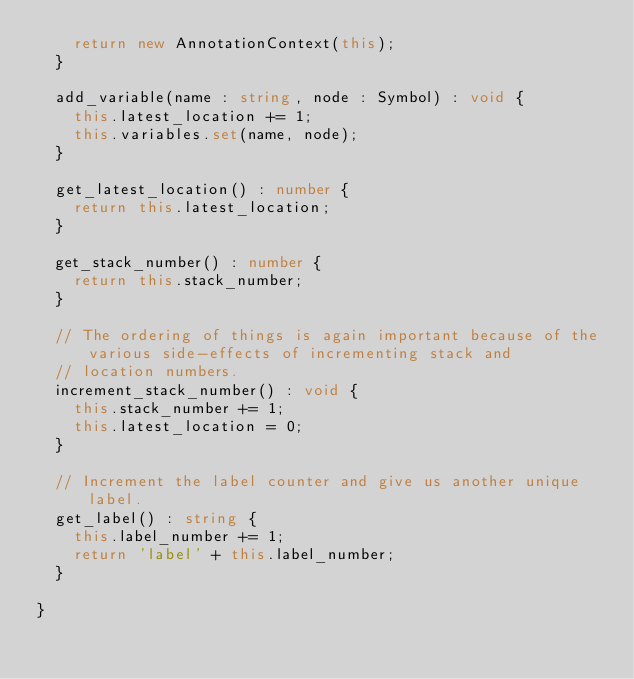<code> <loc_0><loc_0><loc_500><loc_500><_TypeScript_>    return new AnnotationContext(this);
  }

  add_variable(name : string, node : Symbol) : void {
    this.latest_location += 1;
    this.variables.set(name, node);
  }

  get_latest_location() : number {
    return this.latest_location;
  }

  get_stack_number() : number {
    return this.stack_number;
  }

  // The ordering of things is again important because of the various side-effects of incrementing stack and
  // location numbers.
  increment_stack_number() : void {
    this.stack_number += 1;
    this.latest_location = 0;
  }

  // Increment the label counter and give us another unique label.
  get_label() : string {
    this.label_number += 1;
    return 'label' + this.label_number;
  }

}
</code> 